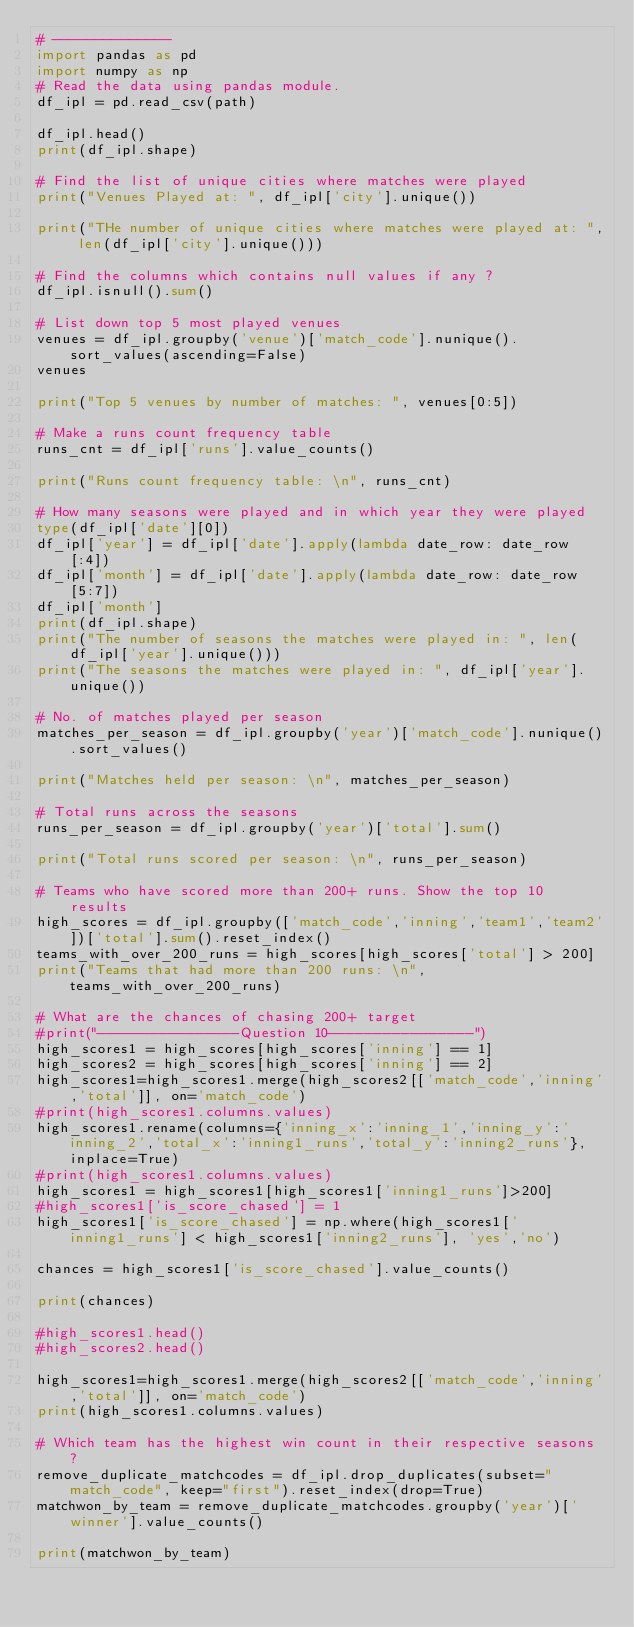<code> <loc_0><loc_0><loc_500><loc_500><_Python_># --------------
import pandas as pd 
import numpy as np
# Read the data using pandas module.
df_ipl = pd.read_csv(path)

df_ipl.head()
print(df_ipl.shape)

# Find the list of unique cities where matches were played
print("Venues Played at: ", df_ipl['city'].unique())

print("THe number of unique cities where matches were played at: ", len(df_ipl['city'].unique()))

# Find the columns which contains null values if any ?
df_ipl.isnull().sum()

# List down top 5 most played venues
venues = df_ipl.groupby('venue')['match_code'].nunique().sort_values(ascending=False)
venues

print("Top 5 venues by number of matches: ", venues[0:5])

# Make a runs count frequency table
runs_cnt = df_ipl['runs'].value_counts()

print("Runs count frequency table: \n", runs_cnt)

# How many seasons were played and in which year they were played 
type(df_ipl['date'][0])
df_ipl['year'] = df_ipl['date'].apply(lambda date_row: date_row[:4])
df_ipl['month'] = df_ipl['date'].apply(lambda date_row: date_row[5:7])
df_ipl['month']
print(df_ipl.shape)
print("The number of seasons the matches were played in: ", len(df_ipl['year'].unique()))
print("The seasons the matches were played in: ", df_ipl['year'].unique())

# No. of matches played per season
matches_per_season = df_ipl.groupby('year')['match_code'].nunique().sort_values()

print("Matches held per season: \n", matches_per_season)

# Total runs across the seasons
runs_per_season = df_ipl.groupby('year')['total'].sum()

print("Total runs scored per season: \n", runs_per_season)

# Teams who have scored more than 200+ runs. Show the top 10 results
high_scores = df_ipl.groupby(['match_code','inning','team1','team2'])['total'].sum().reset_index()
teams_with_over_200_runs = high_scores[high_scores['total'] > 200]
print("Teams that had more than 200 runs: \n",teams_with_over_200_runs)

# What are the chances of chasing 200+ target
#print("----------------Question 10----------------")
high_scores1 = high_scores[high_scores['inning'] == 1]
high_scores2 = high_scores[high_scores['inning'] == 2]
high_scores1=high_scores1.merge(high_scores2[['match_code','inning','total']], on='match_code')
#print(high_scores1.columns.values)
high_scores1.rename(columns={'inning_x':'inning_1','inning_y':'inning_2','total_x':'inning1_runs','total_y':'inning2_runs'}, inplace=True)
#print(high_scores1.columns.values)
high_scores1 = high_scores1[high_scores1['inning1_runs']>200]
#high_scores1['is_score_chased'] = 1
high_scores1['is_score_chased'] = np.where(high_scores1['inning1_runs'] < high_scores1['inning2_runs'], 'yes','no')

chances = high_scores1['is_score_chased'].value_counts()

print(chances)

#high_scores1.head()
#high_scores2.head()

high_scores1=high_scores1.merge(high_scores2[['match_code','inning','total']], on='match_code')
print(high_scores1.columns.values)

# Which team has the highest win count in their respective seasons ?
remove_duplicate_matchcodes = df_ipl.drop_duplicates(subset="match_code", keep="first").reset_index(drop=True)
matchwon_by_team = remove_duplicate_matchcodes.groupby('year')['winner'].value_counts()

print(matchwon_by_team)



</code> 